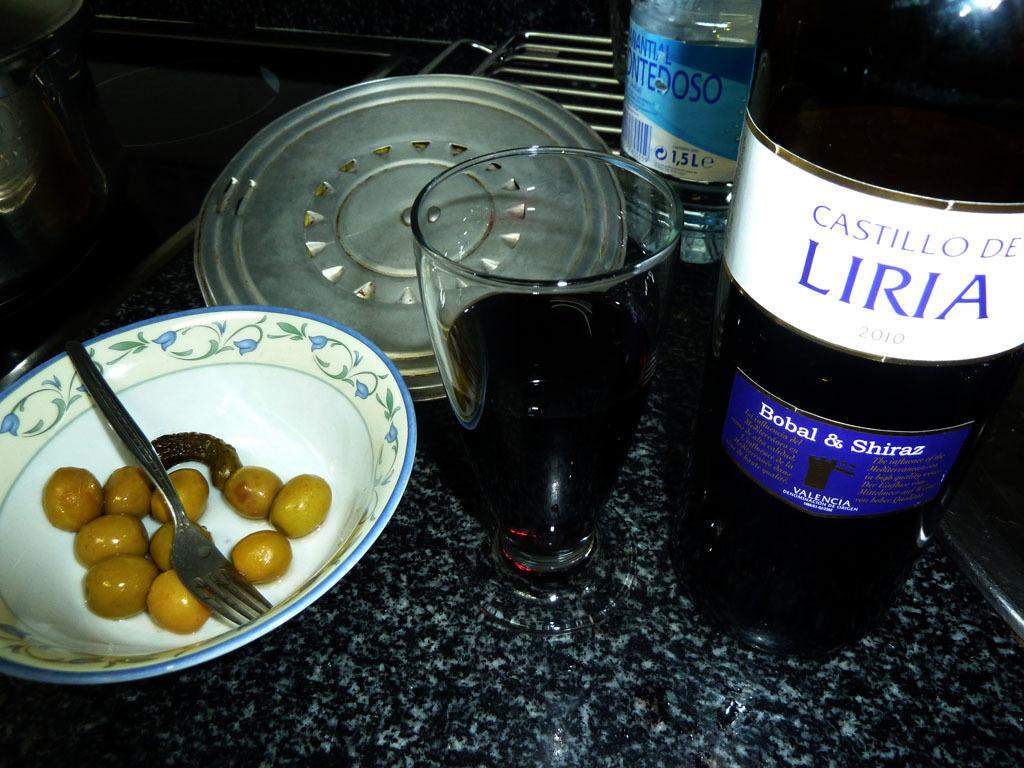What type of objects can be seen in the image? There are bottles, a glass with a drink, and a bowl with food in the image. What utensil is present in the image? There is a fork in the image. Where are these objects located? The objects are on a kitchen platform. How much milk is being poured into the glass in the image? There is no milk visible in the image, and the glass already contains a drink. 